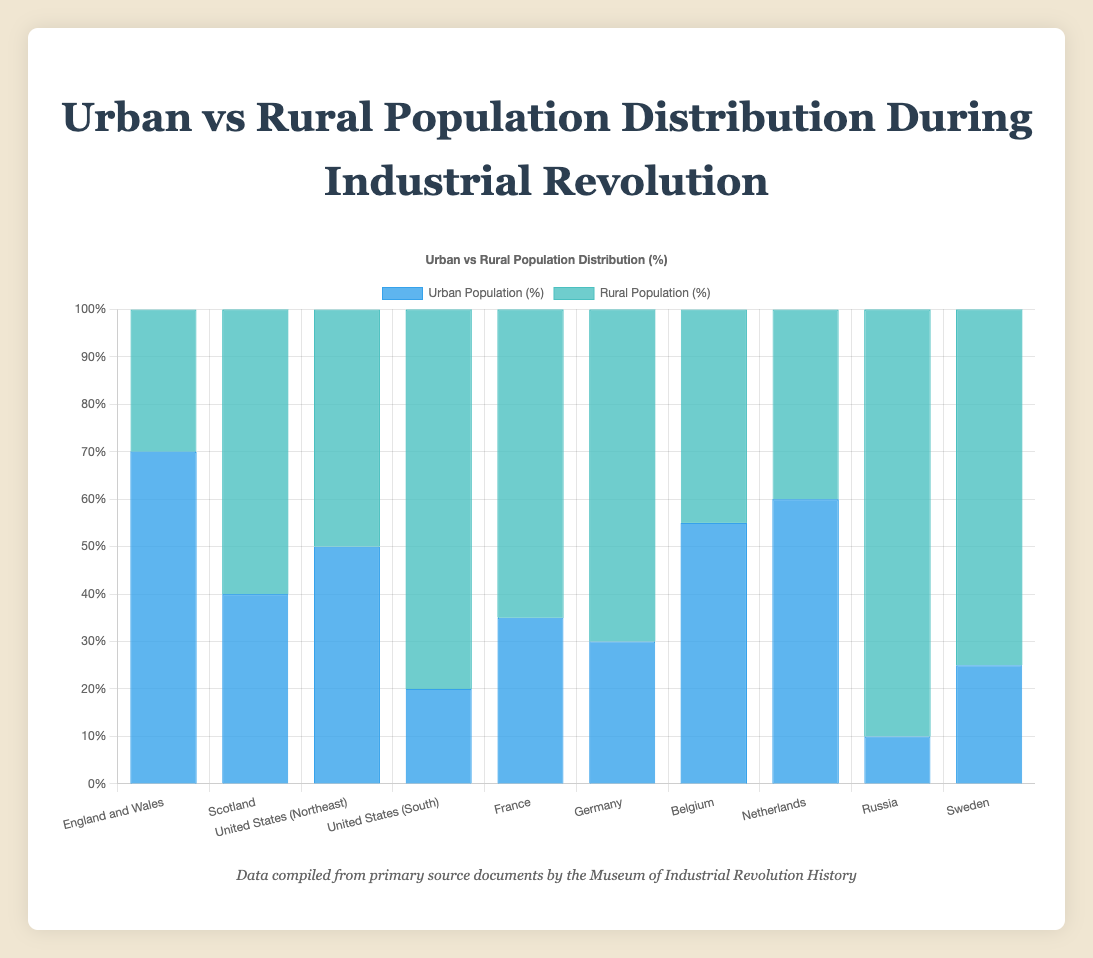Which region has the highest percentage of urban population? Look at the bar for each region and identify the one with the tallest blue bar representing the urban population percentage.
Answer: England and Wales Which region has the lowest percentage of rural population? Identify the region with the shortest bar for the rural population percentage (the green bar).
Answer: England and Wales How does the urban population percentage in Belgium compare to that in the Netherlands? Compare the height of the blue bars for Belgium and the Netherlands. Belgium's blue bar is shorter than that of the Netherlands by 5%.
Answer: Belgium is 5% lower What is the combined urban population percentage of England and Wales and the United States (Northeast)? Add the urban population percentages for England and Wales (70%) and the United States (Northeast) (50%). 70% + 50% = 120%
Answer: 120% Which region has a more balanced distribution between urban and rural populations, Scotland or United States (Northeast)? Look at the urban vs rural percentages for both regions. The United States (Northeast) has a 50-50 balance, while Scotland is 40-60.
Answer: United States (Northeast) What's the difference between the urban population percentages of France and Germany? Subtract the urban population percentage of Germany (30%) from that of France (35%). 35% - 30% = 5%
Answer: 5% Which area shows a greater rural population percentage, Russia or United States (South)? Compare the height of the rural population bars (green) for Russia and the United States (South). Russia's green bar is taller, indicating a higher rural population percentage.
Answer: Russia What percentage of the population in Sweden is rural? Refer to the green bar for Sweden, which represents the rural population percentage.
Answer: 75% If you were to average the urban population percentages of France, Germany, and Belgium, what would the result be? Add the urban population percentages for France (35%), Germany (30%), and Belgium (55%), and then divide by 3. (35 + 30 + 55) / 3 = 40%
Answer: 40% Which regions have a higher percentage of urban population than rural population? Identify regions where the blue bar (urban) is taller than the green bar (rural). These regions are England and Wales, United States (Northeast), Belgium, and Netherlands.
Answer: England and Wales, United States (Northeast), Belgium, Netherlands 